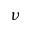<formula> <loc_0><loc_0><loc_500><loc_500>\nu</formula> 